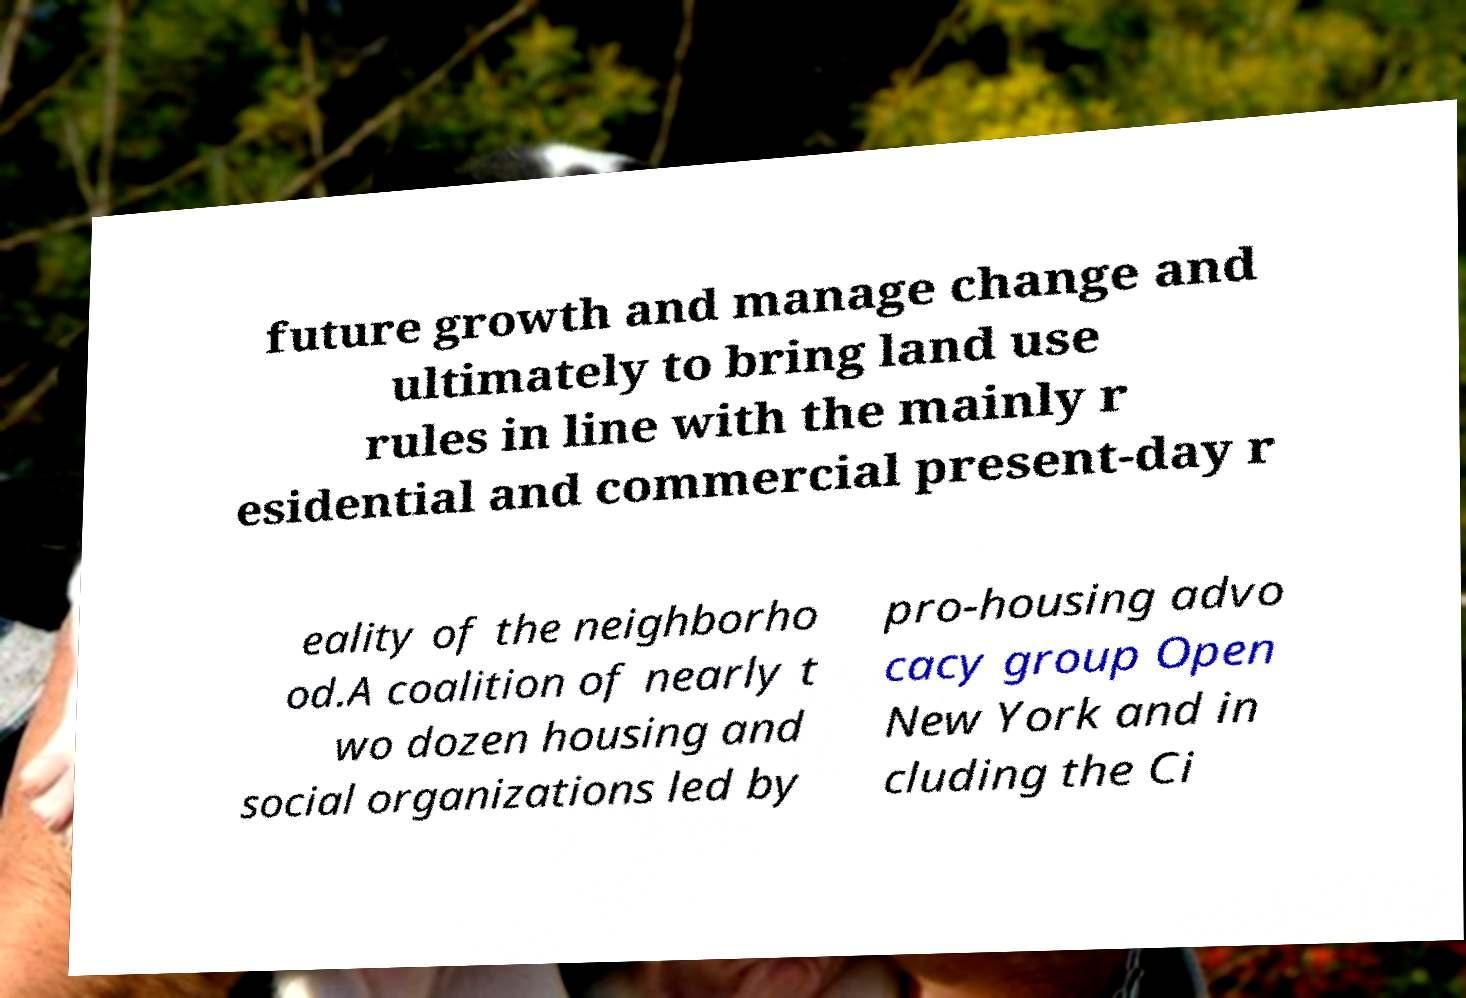Please read and relay the text visible in this image. What does it say? future growth and manage change and ultimately to bring land use rules in line with the mainly r esidential and commercial present-day r eality of the neighborho od.A coalition of nearly t wo dozen housing and social organizations led by pro-housing advo cacy group Open New York and in cluding the Ci 